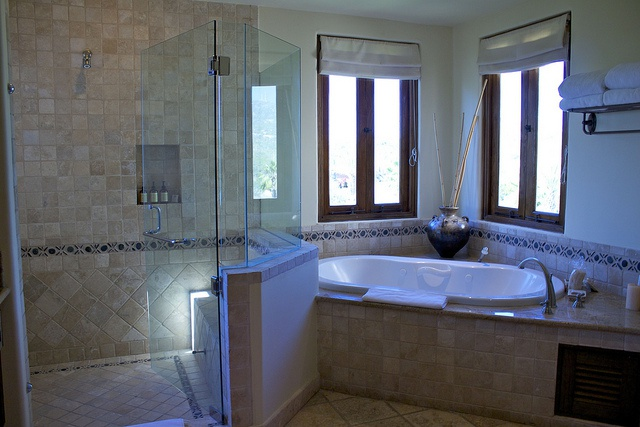Describe the objects in this image and their specific colors. I can see sink in gray and darkgray tones, vase in gray, black, and navy tones, cup in gray and black tones, bottle in gray, black, and blue tones, and bottle in gray and black tones in this image. 